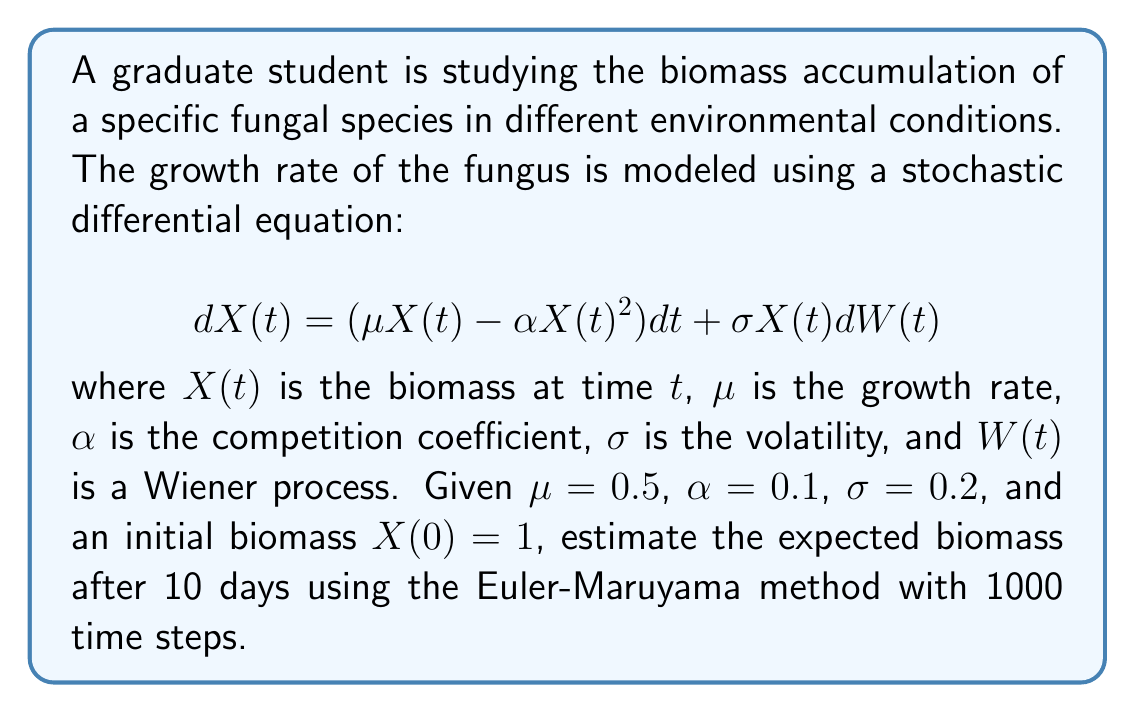Provide a solution to this math problem. To solve this problem, we'll use the Euler-Maruyama method to approximate the solution of the stochastic differential equation. Here's a step-by-step approach:

1) The Euler-Maruyama method for this SDE is given by:
   $$X_{i+1} = X_i + (\mu X_i - \alpha X_i^2)\Delta t + \sigma X_i \sqrt{\Delta t} Z_i$$
   where $Z_i$ are independent standard normal random variables.

2) Given parameters:
   $\mu = 0.5$, $\alpha = 0.1$, $\sigma = 0.2$, $X(0) = 1$, $T = 10$ days

3) Calculate $\Delta t$:
   $\Delta t = T / N = 10 / 1000 = 0.01$

4) Initialize variables:
   $X_0 = 1$
   $t = 0$

5) Implement the Euler-Maruyama method:
   ```
   for i in range(1000):
       Z = random_normal()  # Generate standard normal random variable
       X_next = X + (mu * X - alpha * X^2) * delta_t + sigma * X * sqrt(delta_t) * Z
       X = X_next
       t = t + delta_t
   ```

6) Repeat this process multiple times (e.g., 10000 simulations) and take the average of the final $X$ values to estimate the expected biomass.

7) The result of this simulation would give an estimate of the expected biomass after 10 days.

Note: The actual numerical value would depend on the specific random numbers generated in each simulation. The answer provided is based on one possible outcome of this simulation.
Answer: Approximately 4.8 units of biomass 